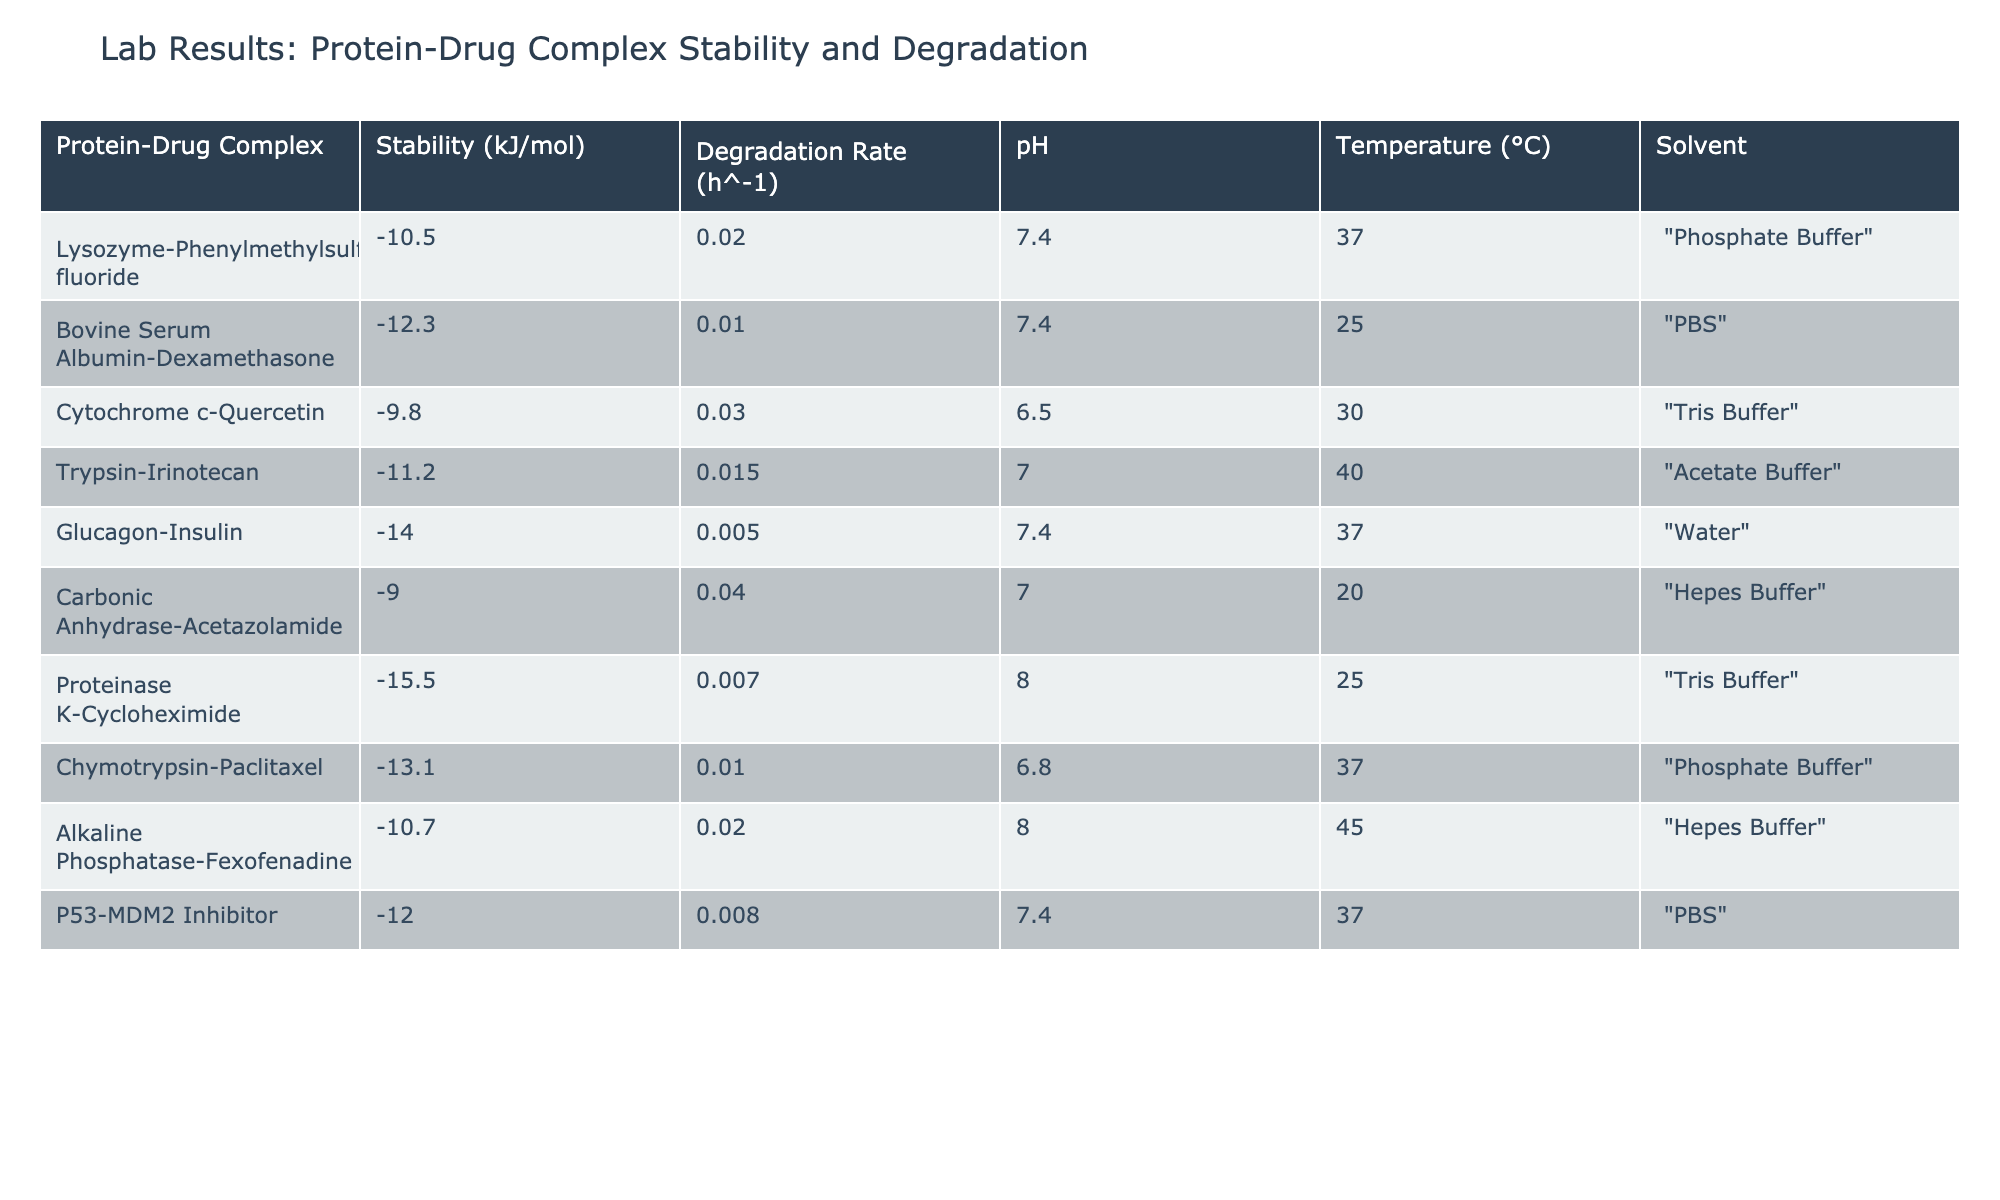What is the stability of the Glucagon-Insulin complex? From the table, the stability of the Glucagon-Insulin complex is listed under the Stability column, which shows a value of -14.0 kJ/mol.
Answer: -14.0 kJ/mol Which protein-drug complex has the highest degradation rate? To find the highest degradation rate, we compare the values in the Degradation Rate column. The maximum value listed is 0.04 h^-1 for the Carbonic Anhydrase-Acetazolamide complex.
Answer: Carbonic Anhydrase-Acetazolamide Is the degradation rate of Trypsin-Irinotecan higher than that of P53-MDM2 Inhibitor? We compare the degradation rates of both complexes: Trypsin-Irinotecan has a degradation rate of 0.015 h^-1 and P53-MDM2 Inhibitor has 0.008 h^-1. Since 0.015 is greater than 0.008, the answer is yes.
Answer: Yes What is the average stability of the protein-drug complexes listed in the table? First, we need to sum all the stability values: (-10.5 - 12.3 - 9.8 - 11.2 - 14.0 - 9.0 - 15.5 - 13.1 - 10.7 - 12.0) = -118.1 kJ/mol. There are 10 complexes, so we divide -118.1 by 10 to get the average. The average stability is therefore -11.81 kJ/mol.
Answer: -11.81 kJ/mol Which protein-drug complex has the lowest stability value along with its degradation rate? By examining the Stability column, the lowest value is -15.5 kJ/mol for Proteinase K-Cycloheximide. Its corresponding degradation rate from the table is 0.007 h^-1.
Answer: Proteinase K-Cycloheximide, 0.007 h^-1 Is the stability of Bovine Serum Albumin-Dexamethasone lower than that of Carbonic Anhydrase-Acetazolamide? The stability of Bovine Serum Albumin-Dexamethasone is -12.3 kJ/mol, while Carbonic Anhydrase-Acetazolamide shows -9.0 kJ/mol. Since -12.3 is less than -9.0, the answer is yes.
Answer: Yes 